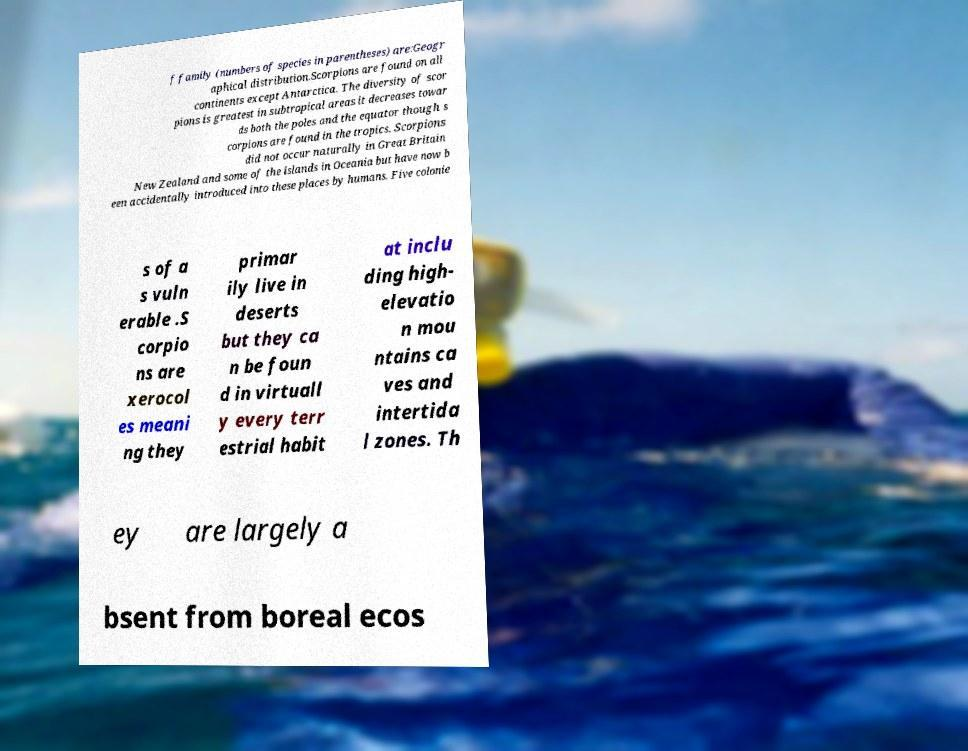Could you extract and type out the text from this image? f family (numbers of species in parentheses) are:Geogr aphical distribution.Scorpions are found on all continents except Antarctica. The diversity of scor pions is greatest in subtropical areas it decreases towar ds both the poles and the equator though s corpions are found in the tropics. Scorpions did not occur naturally in Great Britain New Zealand and some of the islands in Oceania but have now b een accidentally introduced into these places by humans. Five colonie s of a s vuln erable .S corpio ns are xerocol es meani ng they primar ily live in deserts but they ca n be foun d in virtuall y every terr estrial habit at inclu ding high- elevatio n mou ntains ca ves and intertida l zones. Th ey are largely a bsent from boreal ecos 